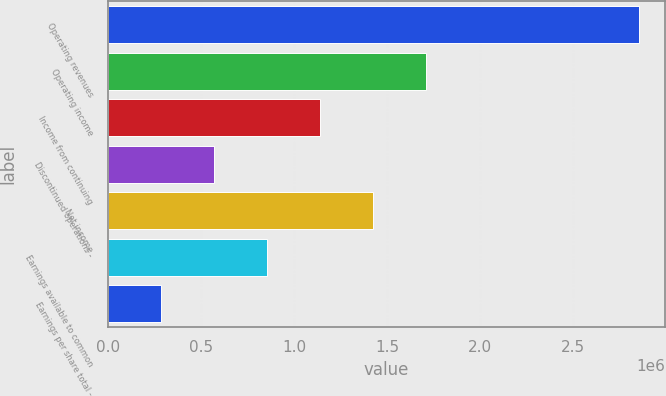Convert chart. <chart><loc_0><loc_0><loc_500><loc_500><bar_chart><fcel>Operating revenues<fcel>Operating income<fcel>Income from continuing<fcel>Discontinued operations -<fcel>Net income<fcel>Earnings available to common<fcel>Earnings per share total -<nl><fcel>2.85168e+06<fcel>1.71101e+06<fcel>1.14067e+06<fcel>570336<fcel>1.42584e+06<fcel>855504<fcel>285168<nl></chart> 